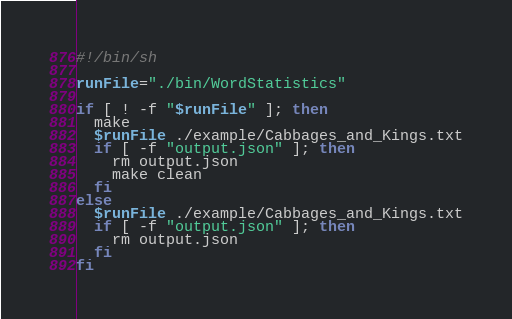<code> <loc_0><loc_0><loc_500><loc_500><_Bash_>#!/bin/sh

runFile="./bin/WordStatistics"

if [ ! -f "$runFile" ]; then
  make
  $runFile ./example/Cabbages_and_Kings.txt
  if [ -f "output.json" ]; then
    rm output.json
    make clean
  fi
else
  $runFile ./example/Cabbages_and_Kings.txt
  if [ -f "output.json" ]; then
    rm output.json
  fi
fi</code> 